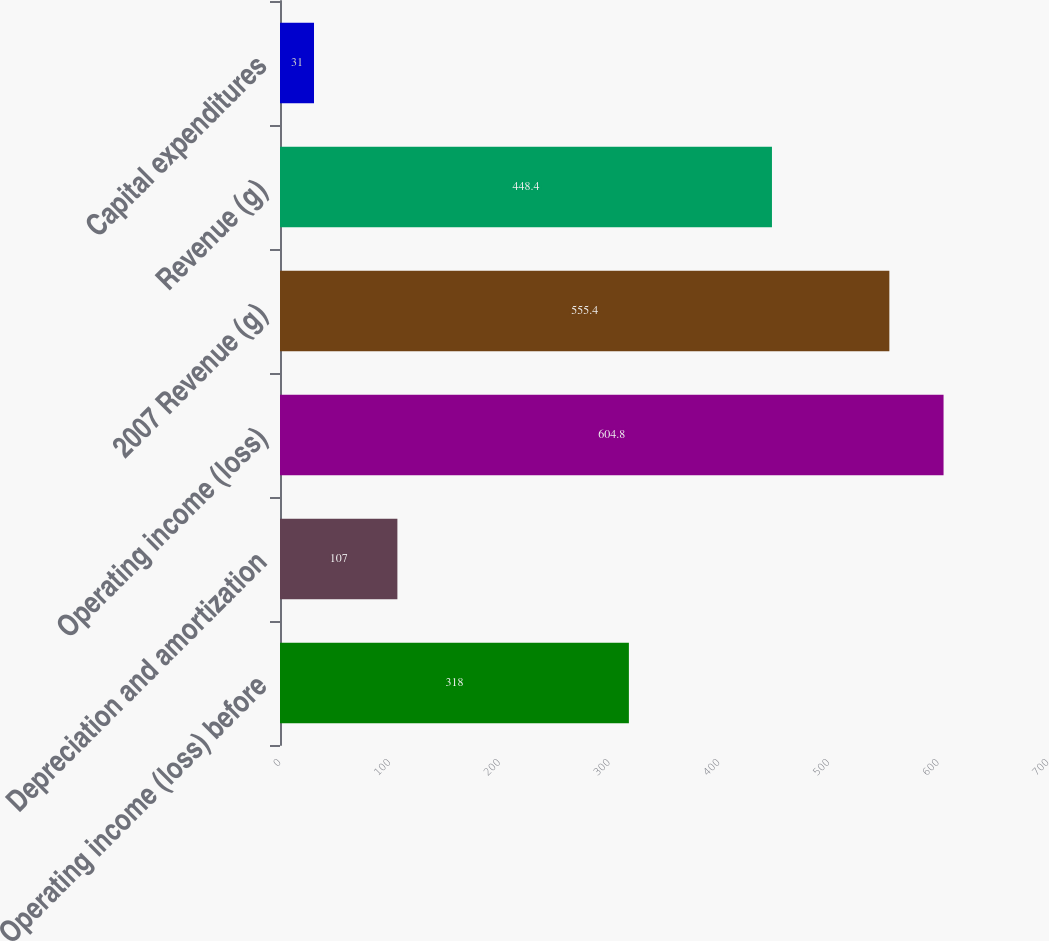<chart> <loc_0><loc_0><loc_500><loc_500><bar_chart><fcel>Operating income (loss) before<fcel>Depreciation and amortization<fcel>Operating income (loss)<fcel>2007 Revenue (g)<fcel>Revenue (g)<fcel>Capital expenditures<nl><fcel>318<fcel>107<fcel>604.8<fcel>555.4<fcel>448.4<fcel>31<nl></chart> 